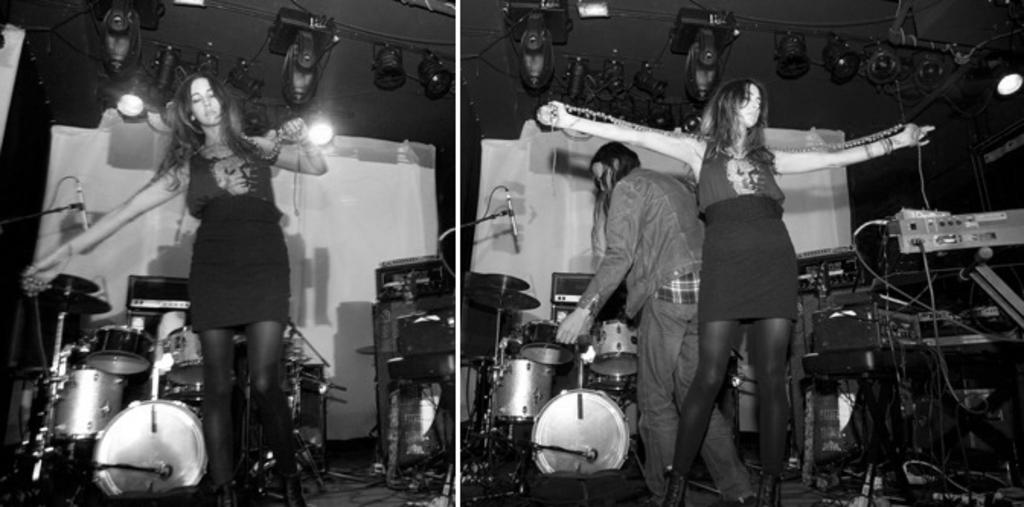How many women are present in the image? There are two women in the image. Can you describe the position of the women in relation to each other? The first woman is in front, and there is another woman behind her. What else can be seen in the image besides the women? There are musical instruments in the image. What type of hat is the woman wearing in the image? There is no hat visible in the image; the women are not wearing any headwear. 